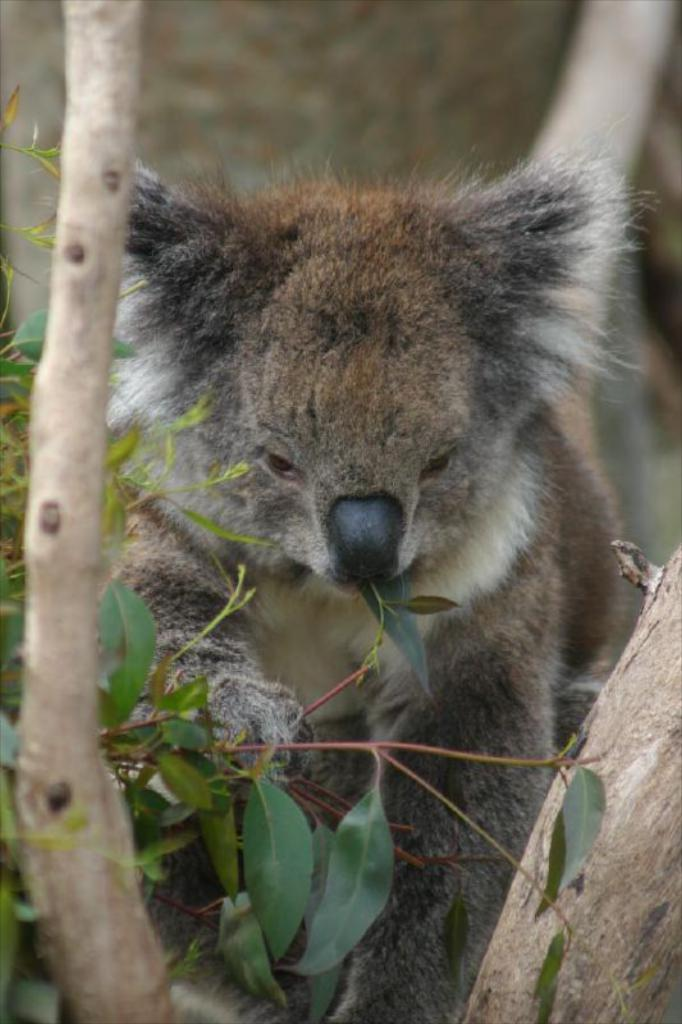What type of animal is in the image? There is an animal in the image, but its specific type cannot be determined from the provided facts. What color is the animal in the image? The animal is brown in color. What is located at the bottom of the image? There is a tree with leaves at the bottom of the image. How would you describe the background of the image? The background of the image is blurred. What type of crime is being committed by the animal in the image? There is no crime being committed by the animal in the image, as the facts provided do not mention any criminal activity. What type of trousers is the animal wearing in the image? There is no mention of trousers or any clothing in the image, as the facts provided only mention the animal's color and the presence of a tree with leaves. 